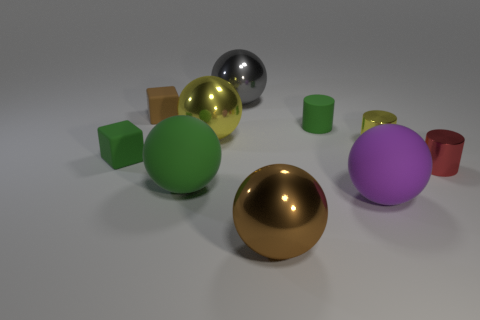Does the yellow thing that is left of the gray metallic ball have the same material as the small green cylinder? no 